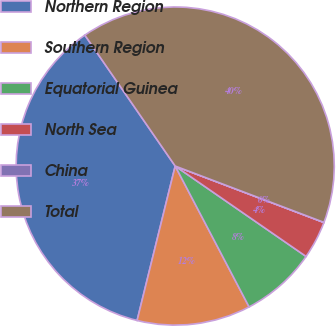Convert chart to OTSL. <chart><loc_0><loc_0><loc_500><loc_500><pie_chart><fcel>Northern Region<fcel>Southern Region<fcel>Equatorial Guinea<fcel>North Sea<fcel>China<fcel>Total<nl><fcel>36.54%<fcel>11.54%<fcel>7.69%<fcel>3.85%<fcel>0.01%<fcel>40.38%<nl></chart> 